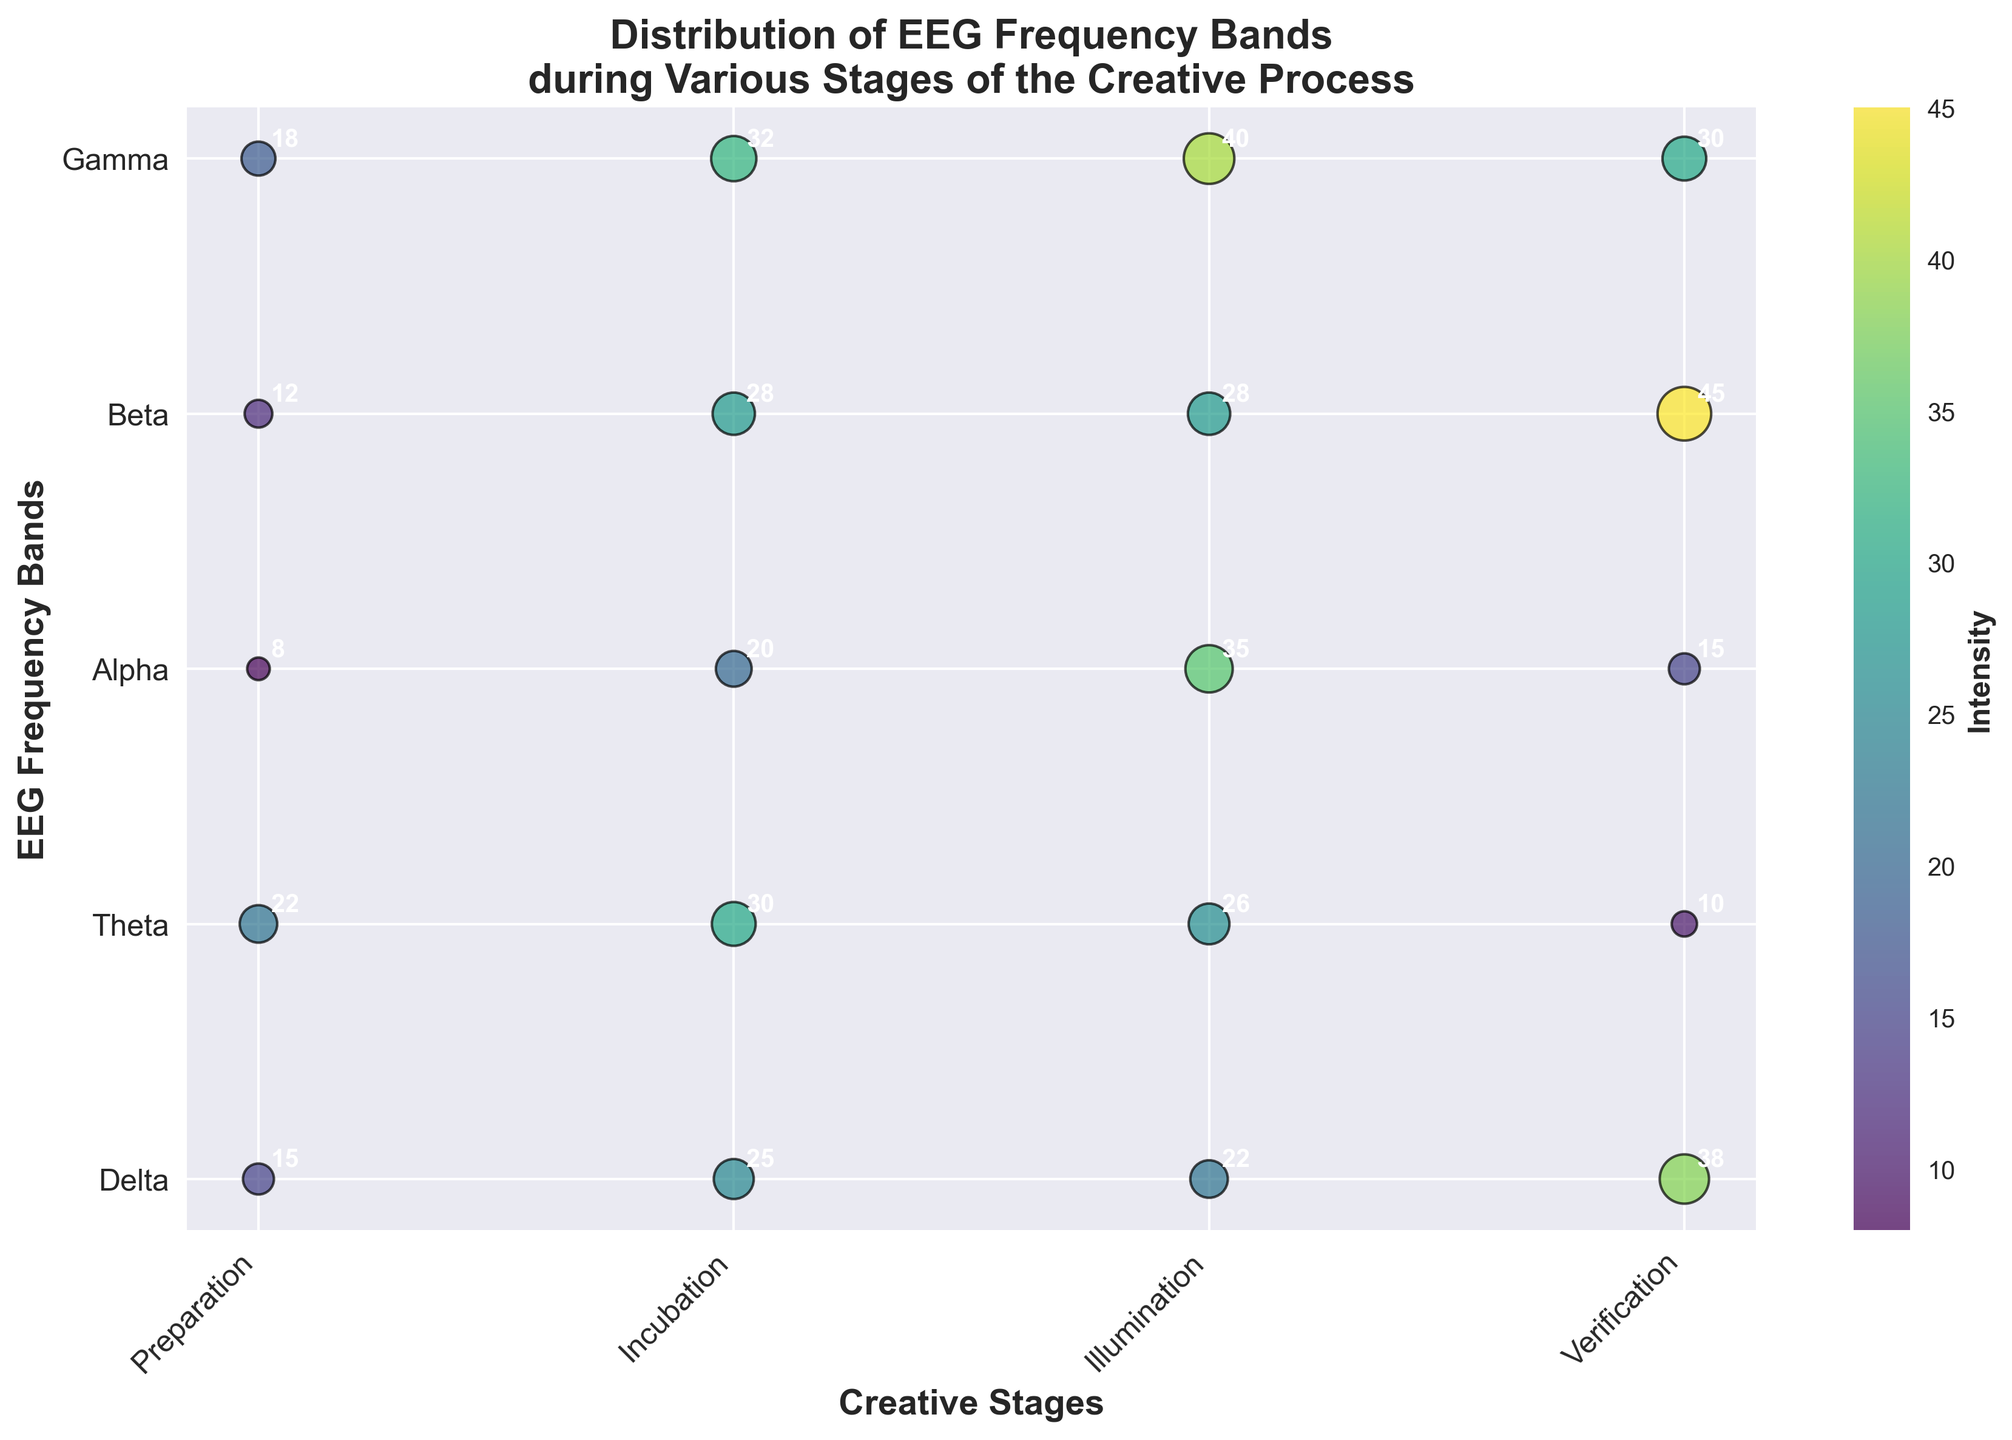What are the EEG frequency bands represented on the y-axis? The y-axis labels indicate the EEG frequency bands. By looking at the y-axis, we can see that it includes Delta, Theta, Alpha, Beta, and Gamma.
Answer: Delta, Theta, Alpha, Beta, Gamma What is the title of the plot? The title is located at the top of the plot. The title of this plot is "Distribution of EEG Frequency Bands during Various Stages of the Creative Process".
Answer: Distribution of EEG Frequency Bands during Various Stages of the Creative Process Which EEG frequency band shows the highest intensity during the Illumination stage? Locate the Illumination stage on the x-axis, then find the highest data point in terms of circle size for this stage along the y-axis (EEG frequency bands). Gamma shows the highest intensity value of 45.
Answer: Gamma What is the average intensity for the Theta frequency band across all creative stages? First, locate all data points for the Theta frequency band. The intensities are 18, 25, 30, and 20. Summing these values and then dividing by the count (4) gives the average. Calculation: (18 + 25 + 30 + 20) / 4 = 23.25
Answer: 23.25 Which creative stage has the lowest average intensity across all frequency bands? Calculate the average intensity for each creative stage by summing the intensities of all EEG frequency bands for each stage and then dividing by the number of bands (5). The stage with the smallest average is the answer.
Preparation: (15+18+28+35+10)/5 = 21.2
Incubation: (22+25+32+28+15)/5 = 24.4
Illumination: (8+30+22+40+45)/5 = 29
Verification: (12+20+26+38+30)/5 = 25.2 
Preparation has the lowest average.
Answer: Preparation What is the color legend representing? The color legend or color bar shows the gradient used to represent different intensities. It indicates that the colors range from lower to higher intensities.
Answer: Intensity Between Beta and Gamma frequency bands, which one has a higher overall intensity during the Incubation stage? Locate both Beta and Gamma data points for the Incubation stage on the figure. Beta has an intensity of 28, and Gamma has an intensity of 15. Beta has a higher intensity.
Answer: Beta What is the total intensity for the Alpha frequency band across all creative stages? Locate the Alpha frequency band intensities for all stages: Preparation (28), Incubation (32), Illumination (22), Verification (26). Sum these values: 28 + 32 + 22 + 26 = 108
Answer: 108 Which EEG frequency band shows the greatest increase in intensity from the Preparation stage to the Illumination stage? Calculate the intensity difference for each frequency band between the Preparation and Illumination stages. Delta (8-15=-7), Theta (30-18=12), Alpha (22-28=-6), Beta (40-35=5), Gamma (45-10=35). Gamma has the greatest increase (35).
Answer: Gamma Is there any frequency band that does not show a decrease in intensity from any stage to the next? Examine the intensities for all frequency bands across the stages: Delta (15, 22, 8, 12), Theta (18, 25, 30, 20), Alpha (28, 32, 22, 26), Beta (35, 28, 40, 38), Gamma (10, 15, 45, 30). Theta does not show a decrease from any stage to the next.
Answer: Theta 